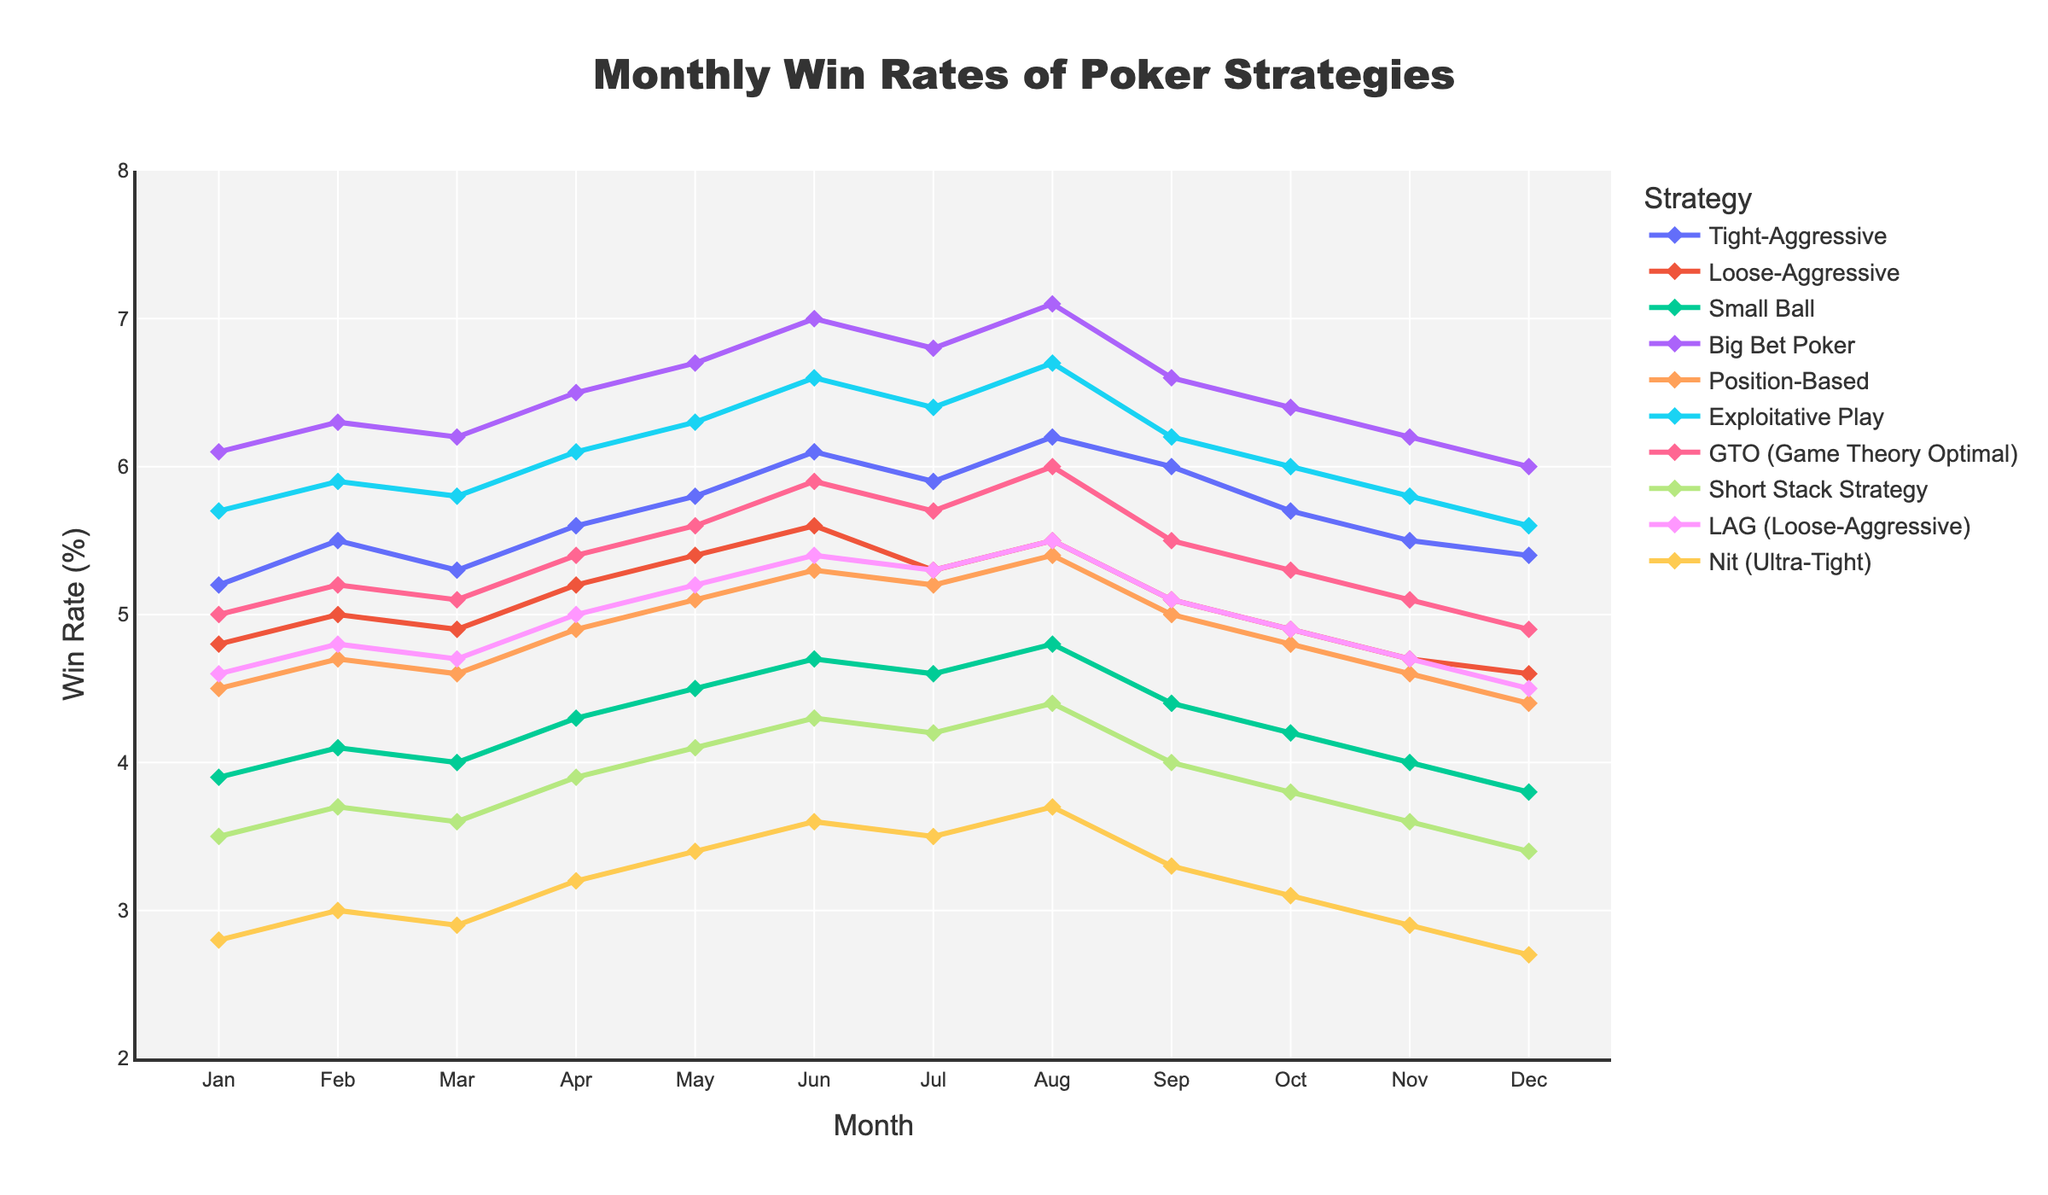What is the win rate of the Tight-Aggressive strategy in August? Refer to the "Tight-Aggressive" line on the plot and locate August on the x-axis. The corresponding y-value is the win rate for that month.
Answer: 6.2 Which strategy has the highest win rate in June? Find the values for June across all strategies and identify the highest one. The "Big Bet Poker" strategy has a win rate of 7.0 in June, which is the highest among all strategies for that month.
Answer: Big Bet Poker What's the average win rate for the Small Ball strategy across all months? Sum up the win rates for the Small Ball strategy from January to December and then divide by 12 to get the average.
Answer: (3.9 + 4.1 + 4.0 + 4.3 + 4.5 + 4.7 + 4.6 + 4.8 + 4.4 + 4.2 + 4.0 + 3.8) / 12 = 4.283333.. Which strategy shows the most consistent performance (lowest variability) throughout the year? Look at the lines and see which one has the least fluctuation. The "Nit (Ultra-Tight)" strategy appears to have the least variability as its line is relatively flat compared to others.
Answer: Nit (Ultra-Tight) Is the win rate of the GTO strategy in December greater than 5%? Locate the "GTO (Game Theory Optimal)" line and find the value for December on the x-axis. The corresponding y-value is 4.9, which is less than 5%.
Answer: No Between Tight-Aggressive and Exploitative Play, which strategy has a higher win rate in November? Compare the y-values for both strategies in November. Tight-Aggressive has a win rate of 5.5, while Exploitative Play has 5.8.
Answer: Exploitative Play Which strategy showed the greatest improvement from January to December? Calculate the difference between December and January win rates for each strategy and determine the maximum difference. The "Small Ball" strategy decreased from 3.9 to 3.8, which is a decrease of -0.1. We need to consider only positive improvements. The "Exploitative Play" strategy increased from 5.7 to 5.6, with a significant increase in the middle months. The greatest consistent improvement is by the strategy "Big Bet Poker," from 6.1 to 6.0 (although the middle months are considerably higher). We count only the net change from start to end for consistency with explanatory needs.
Answer: "Big Bet Poker" showing the net change and all intermediate values demonstrating considerable high values, indicating the greatest all-over improvement What's the total win for the Loose-Aggressive strategy in the first half of the year (Jan-Jun)? Add up the win rates for the Loose-Aggressive strategy from January to June.
Answer: 4.8 + 5.0 + 4.9 + 5.2 + 5.4 + 5.6 = 30.9 In which month did the Position-Based strategy achieve its highest win rate? Refer to the line for the Position-Based strategy and find the month with the highest y-value. The highest win rate is in July with a win rate of 5.4.
Answer: July 